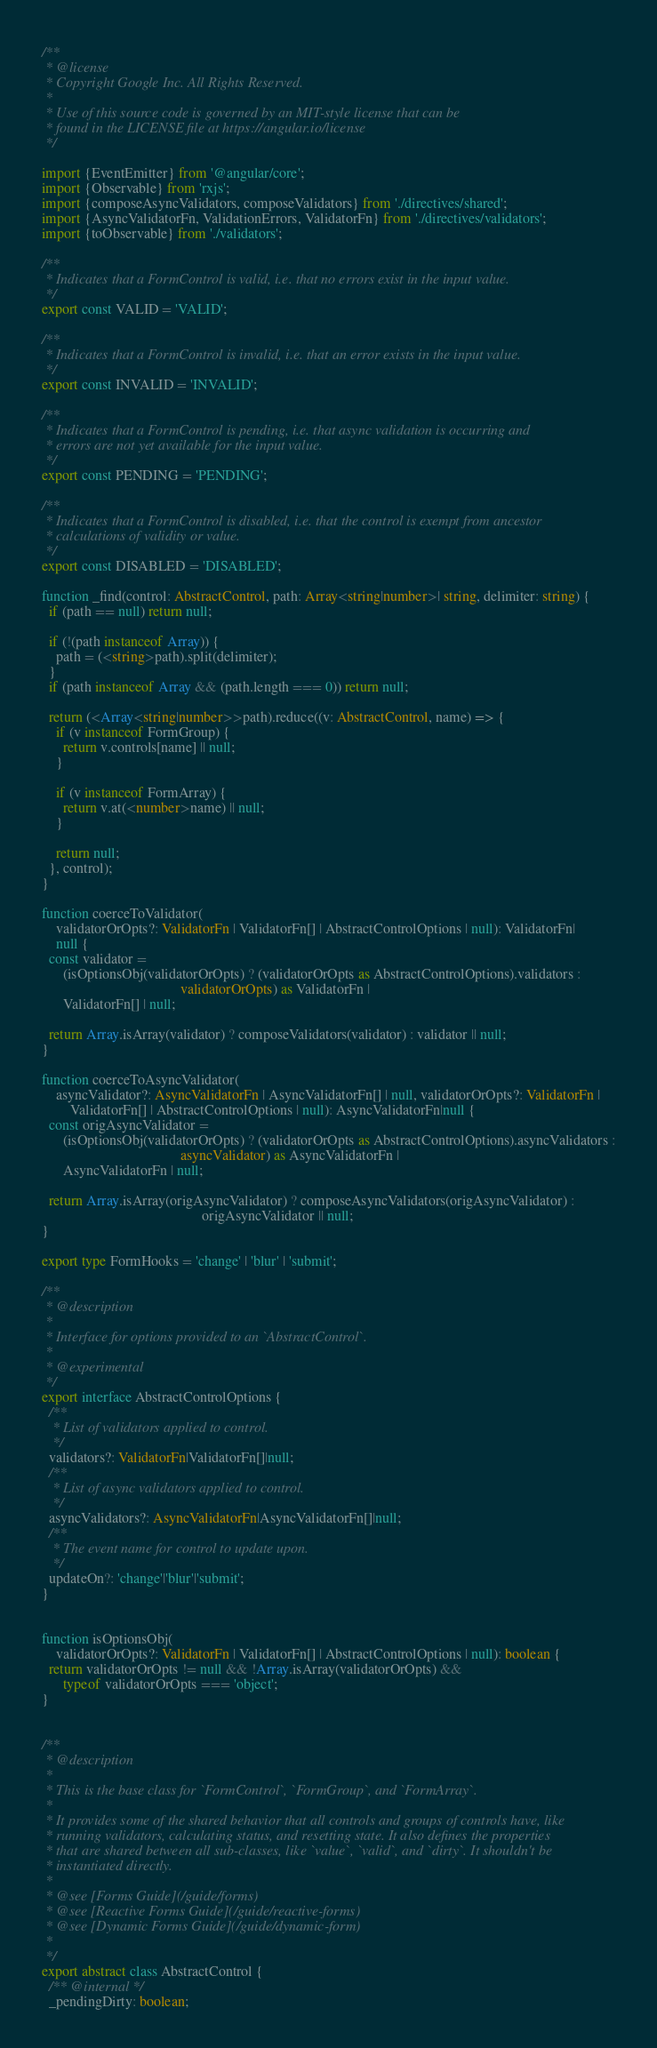Convert code to text. <code><loc_0><loc_0><loc_500><loc_500><_TypeScript_>/**
 * @license
 * Copyright Google Inc. All Rights Reserved.
 *
 * Use of this source code is governed by an MIT-style license that can be
 * found in the LICENSE file at https://angular.io/license
 */

import {EventEmitter} from '@angular/core';
import {Observable} from 'rxjs';
import {composeAsyncValidators, composeValidators} from './directives/shared';
import {AsyncValidatorFn, ValidationErrors, ValidatorFn} from './directives/validators';
import {toObservable} from './validators';

/**
 * Indicates that a FormControl is valid, i.e. that no errors exist in the input value.
 */
export const VALID = 'VALID';

/**
 * Indicates that a FormControl is invalid, i.e. that an error exists in the input value.
 */
export const INVALID = 'INVALID';

/**
 * Indicates that a FormControl is pending, i.e. that async validation is occurring and
 * errors are not yet available for the input value.
 */
export const PENDING = 'PENDING';

/**
 * Indicates that a FormControl is disabled, i.e. that the control is exempt from ancestor
 * calculations of validity or value.
 */
export const DISABLED = 'DISABLED';

function _find(control: AbstractControl, path: Array<string|number>| string, delimiter: string) {
  if (path == null) return null;

  if (!(path instanceof Array)) {
    path = (<string>path).split(delimiter);
  }
  if (path instanceof Array && (path.length === 0)) return null;

  return (<Array<string|number>>path).reduce((v: AbstractControl, name) => {
    if (v instanceof FormGroup) {
      return v.controls[name] || null;
    }

    if (v instanceof FormArray) {
      return v.at(<number>name) || null;
    }

    return null;
  }, control);
}

function coerceToValidator(
    validatorOrOpts?: ValidatorFn | ValidatorFn[] | AbstractControlOptions | null): ValidatorFn|
    null {
  const validator =
      (isOptionsObj(validatorOrOpts) ? (validatorOrOpts as AbstractControlOptions).validators :
                                       validatorOrOpts) as ValidatorFn |
      ValidatorFn[] | null;

  return Array.isArray(validator) ? composeValidators(validator) : validator || null;
}

function coerceToAsyncValidator(
    asyncValidator?: AsyncValidatorFn | AsyncValidatorFn[] | null, validatorOrOpts?: ValidatorFn |
        ValidatorFn[] | AbstractControlOptions | null): AsyncValidatorFn|null {
  const origAsyncValidator =
      (isOptionsObj(validatorOrOpts) ? (validatorOrOpts as AbstractControlOptions).asyncValidators :
                                       asyncValidator) as AsyncValidatorFn |
      AsyncValidatorFn | null;

  return Array.isArray(origAsyncValidator) ? composeAsyncValidators(origAsyncValidator) :
                                             origAsyncValidator || null;
}

export type FormHooks = 'change' | 'blur' | 'submit';

/**
 * @description
 *
 * Interface for options provided to an `AbstractControl`.
 *
 * @experimental
 */
export interface AbstractControlOptions {
  /**
   * List of validators applied to control.
   */
  validators?: ValidatorFn|ValidatorFn[]|null;
  /**
   * List of async validators applied to control.
   */
  asyncValidators?: AsyncValidatorFn|AsyncValidatorFn[]|null;
  /**
   * The event name for control to update upon.
   */
  updateOn?: 'change'|'blur'|'submit';
}


function isOptionsObj(
    validatorOrOpts?: ValidatorFn | ValidatorFn[] | AbstractControlOptions | null): boolean {
  return validatorOrOpts != null && !Array.isArray(validatorOrOpts) &&
      typeof validatorOrOpts === 'object';
}


/**
 * @description
 *
 * This is the base class for `FormControl`, `FormGroup`, and `FormArray`.
 *
 * It provides some of the shared behavior that all controls and groups of controls have, like
 * running validators, calculating status, and resetting state. It also defines the properties
 * that are shared between all sub-classes, like `value`, `valid`, and `dirty`. It shouldn't be
 * instantiated directly.
 *
 * @see [Forms Guide](/guide/forms)
 * @see [Reactive Forms Guide](/guide/reactive-forms)
 * @see [Dynamic Forms Guide](/guide/dynamic-form)
 *
 */
export abstract class AbstractControl {
  /** @internal */
  _pendingDirty: boolean;
</code> 